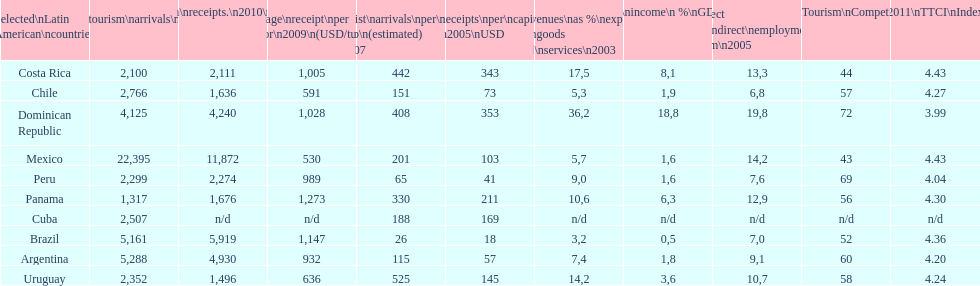Which country had the least amount of tourism income in 2003? Brazil. 